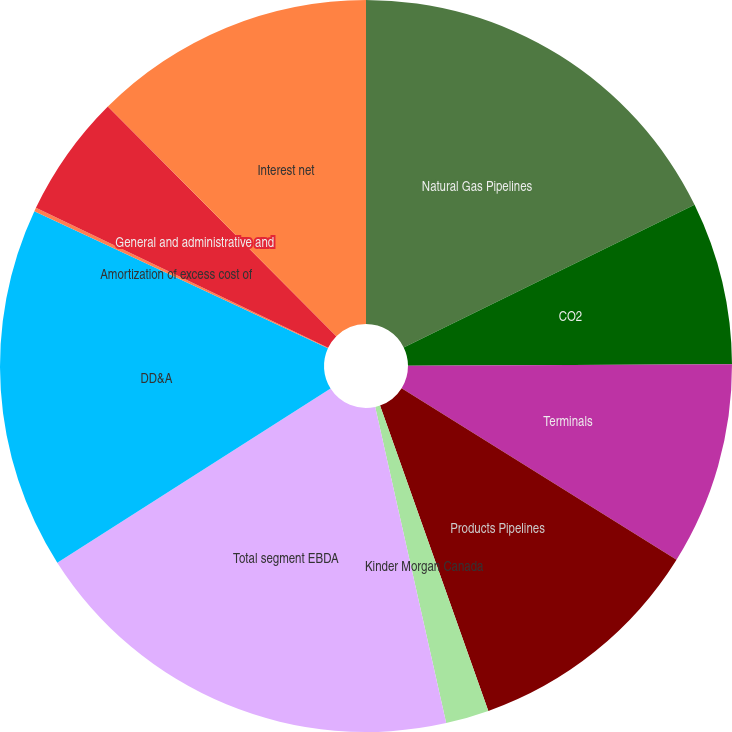<chart> <loc_0><loc_0><loc_500><loc_500><pie_chart><fcel>Natural Gas Pipelines<fcel>CO2<fcel>Terminals<fcel>Products Pipelines<fcel>Kinder Morgan Canada<fcel>Total segment EBDA<fcel>DD&A<fcel>Amortization of excess cost of<fcel>General and administrative and<fcel>Interest net<nl><fcel>17.74%<fcel>7.19%<fcel>8.95%<fcel>10.7%<fcel>1.91%<fcel>19.49%<fcel>15.98%<fcel>0.16%<fcel>5.43%<fcel>12.46%<nl></chart> 